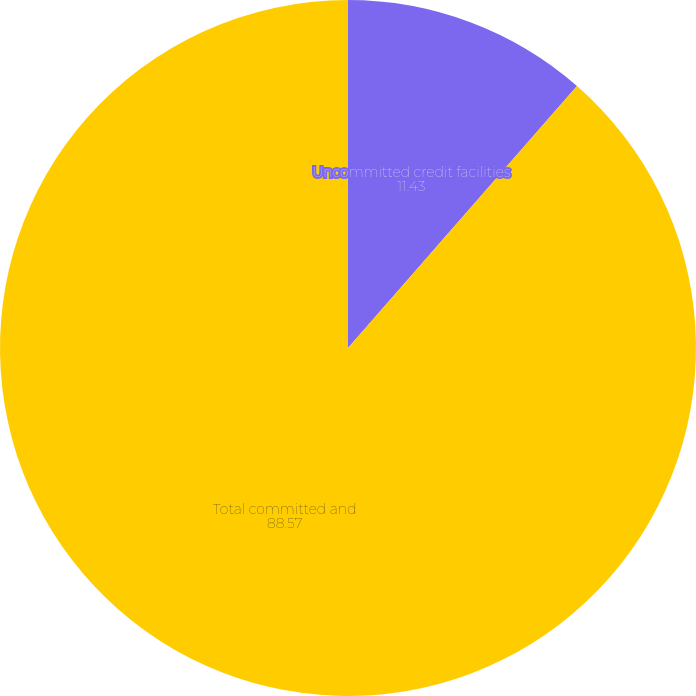<chart> <loc_0><loc_0><loc_500><loc_500><pie_chart><fcel>Uncommitted credit facilities<fcel>Total committed and<nl><fcel>11.43%<fcel>88.57%<nl></chart> 